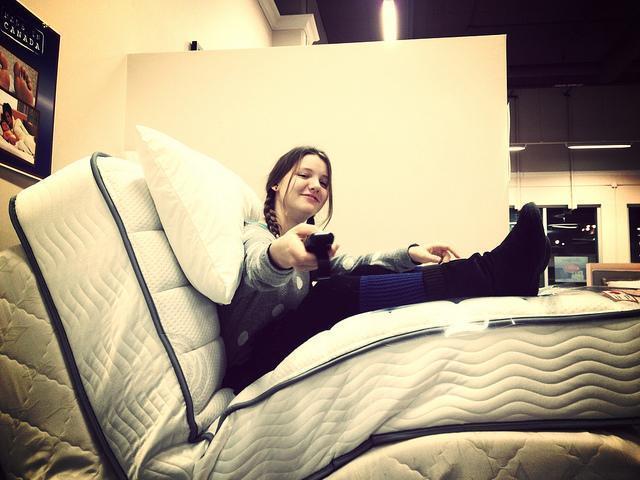How many beds are there?
Give a very brief answer. 1. 